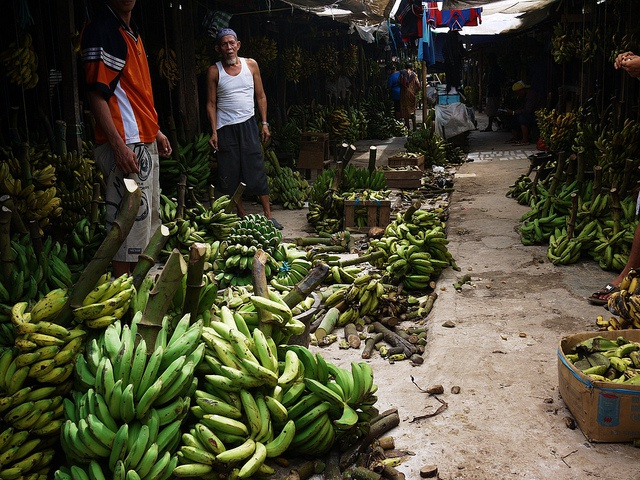Describe the objects in this image and their specific colors. I can see banana in black, darkgreen, and olive tones, people in black, maroon, and gray tones, people in black, lavender, maroon, and gray tones, banana in black and olive tones, and banana in black, darkgreen, and green tones in this image. 